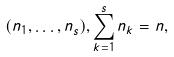Convert formula to latex. <formula><loc_0><loc_0><loc_500><loc_500>( n _ { 1 } , \dots , n _ { s } ) , \sum _ { k = 1 } ^ { s } n _ { k } = n ,</formula> 